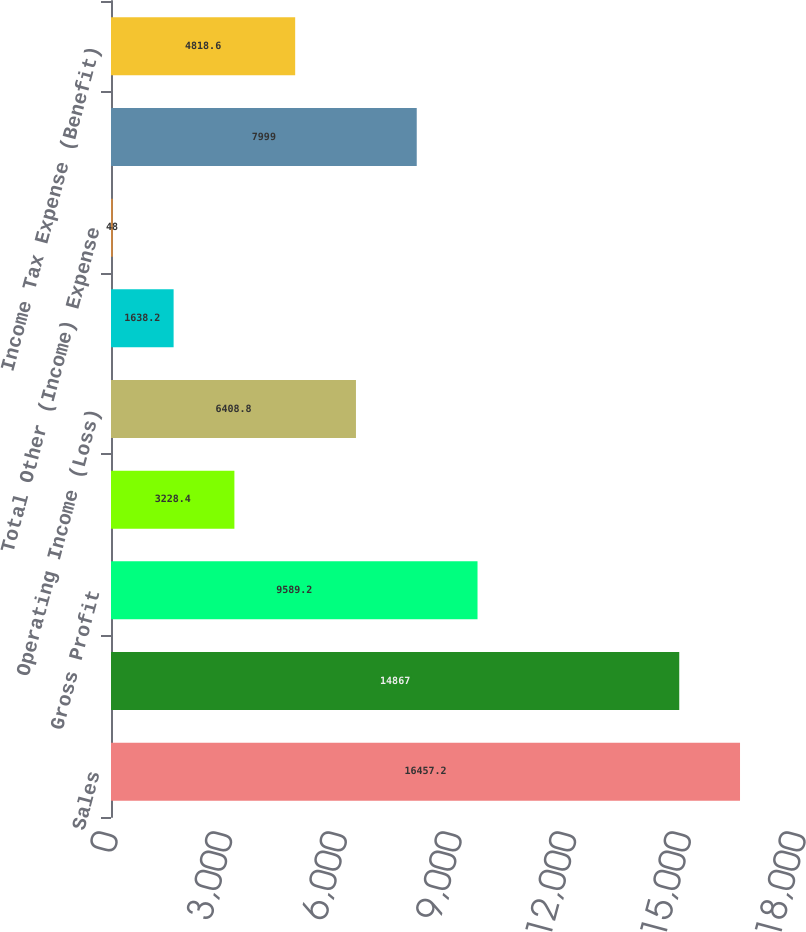Convert chart to OTSL. <chart><loc_0><loc_0><loc_500><loc_500><bar_chart><fcel>Sales<fcel>Cost of Sales<fcel>Gross Profit<fcel>Selling general and<fcel>Operating Income (Loss)<fcel>Equity in net earnings of<fcel>Total Other (Income) Expense<fcel>Income (Loss) from Continuing<fcel>Income Tax Expense (Benefit)<nl><fcel>16457.2<fcel>14867<fcel>9589.2<fcel>3228.4<fcel>6408.8<fcel>1638.2<fcel>48<fcel>7999<fcel>4818.6<nl></chart> 